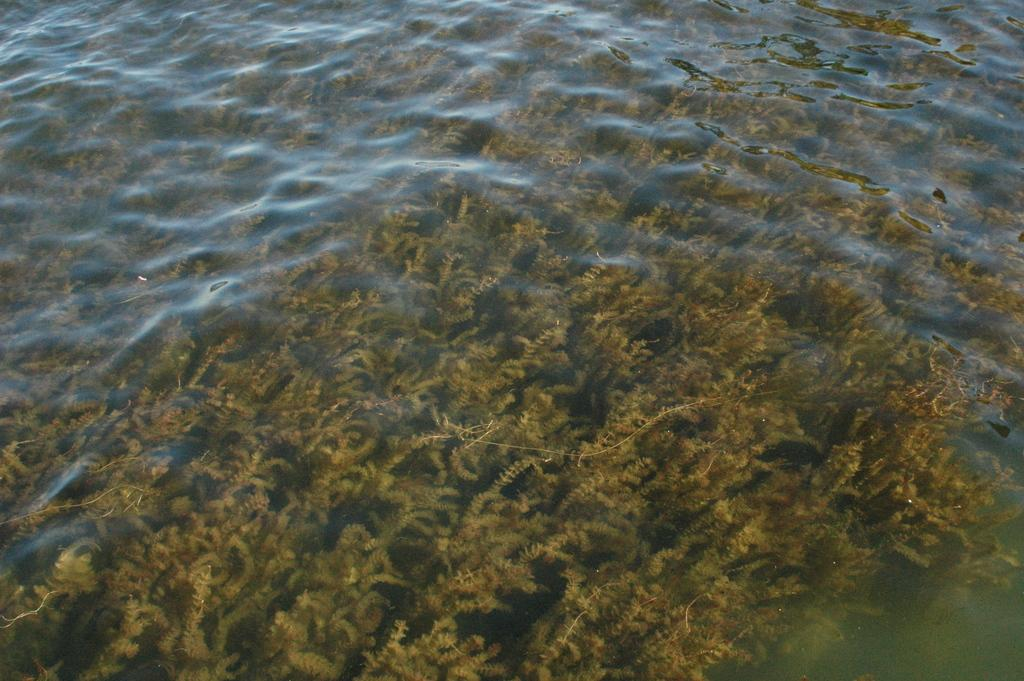What type of plants are in the image? There are water plants in the image. What is the primary element in which the plants are situated? The plants are situated in water. What position does the wave hold in the image? There is no wave present in the image; it features water plants in water. 